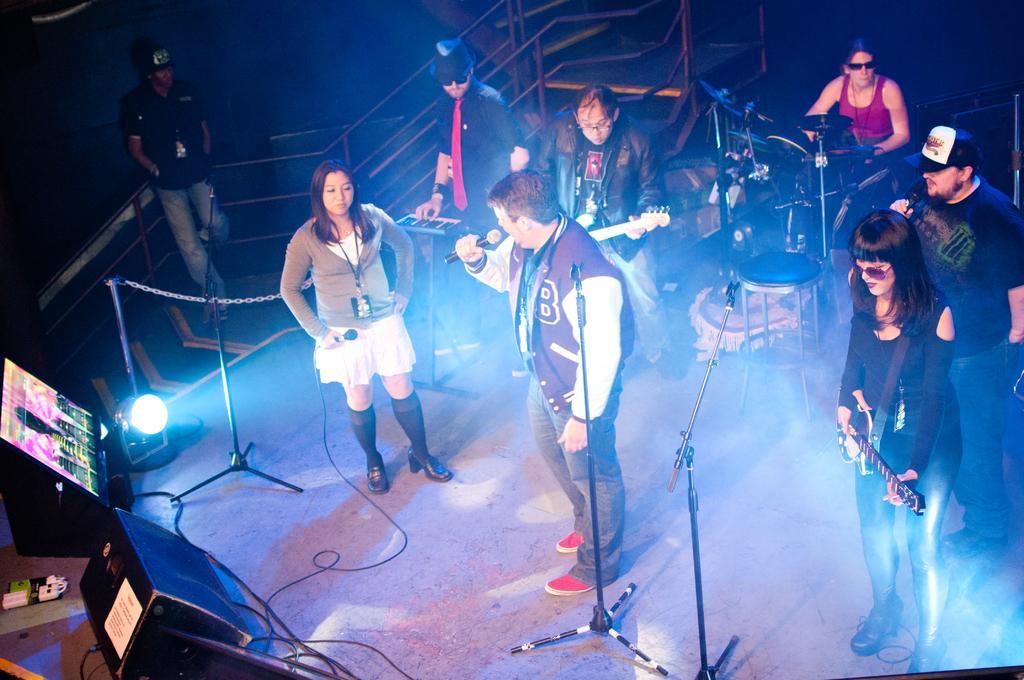How would you summarize this image in a sentence or two? In the image there are many people playing various musical instruments and in the middle there is a man singing song in the mic, there are lights on either side of the stage with a screen of it. 